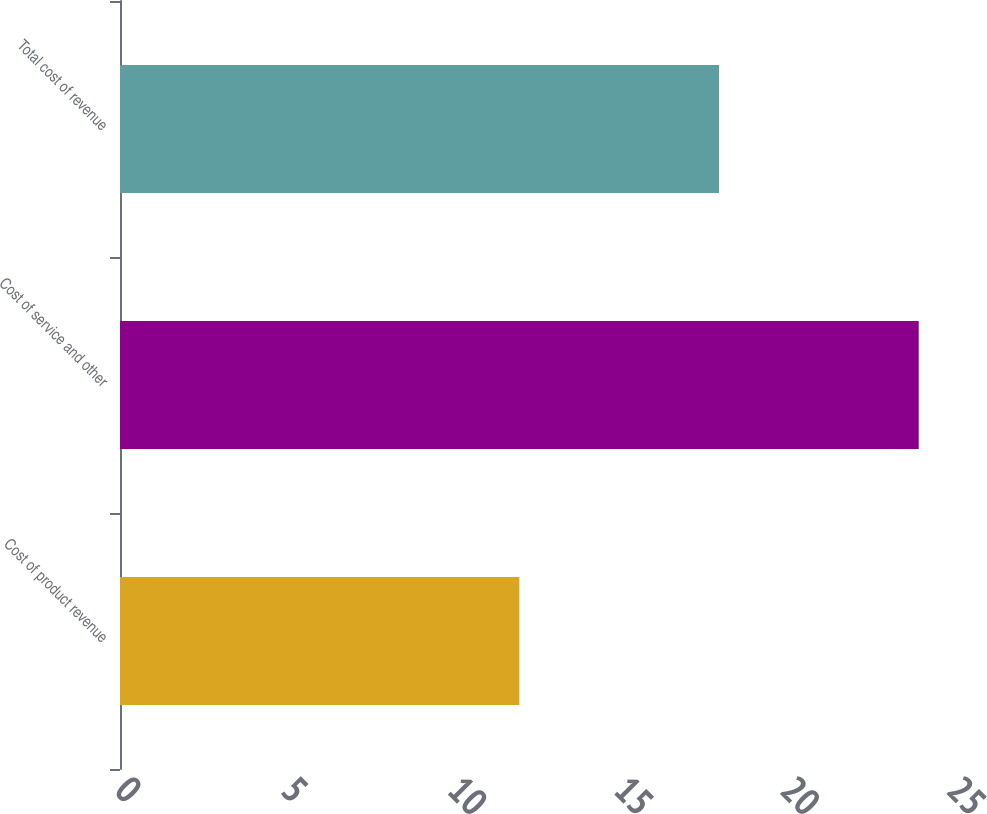Convert chart. <chart><loc_0><loc_0><loc_500><loc_500><bar_chart><fcel>Cost of product revenue<fcel>Cost of service and other<fcel>Total cost of revenue<nl><fcel>12<fcel>24<fcel>18<nl></chart> 